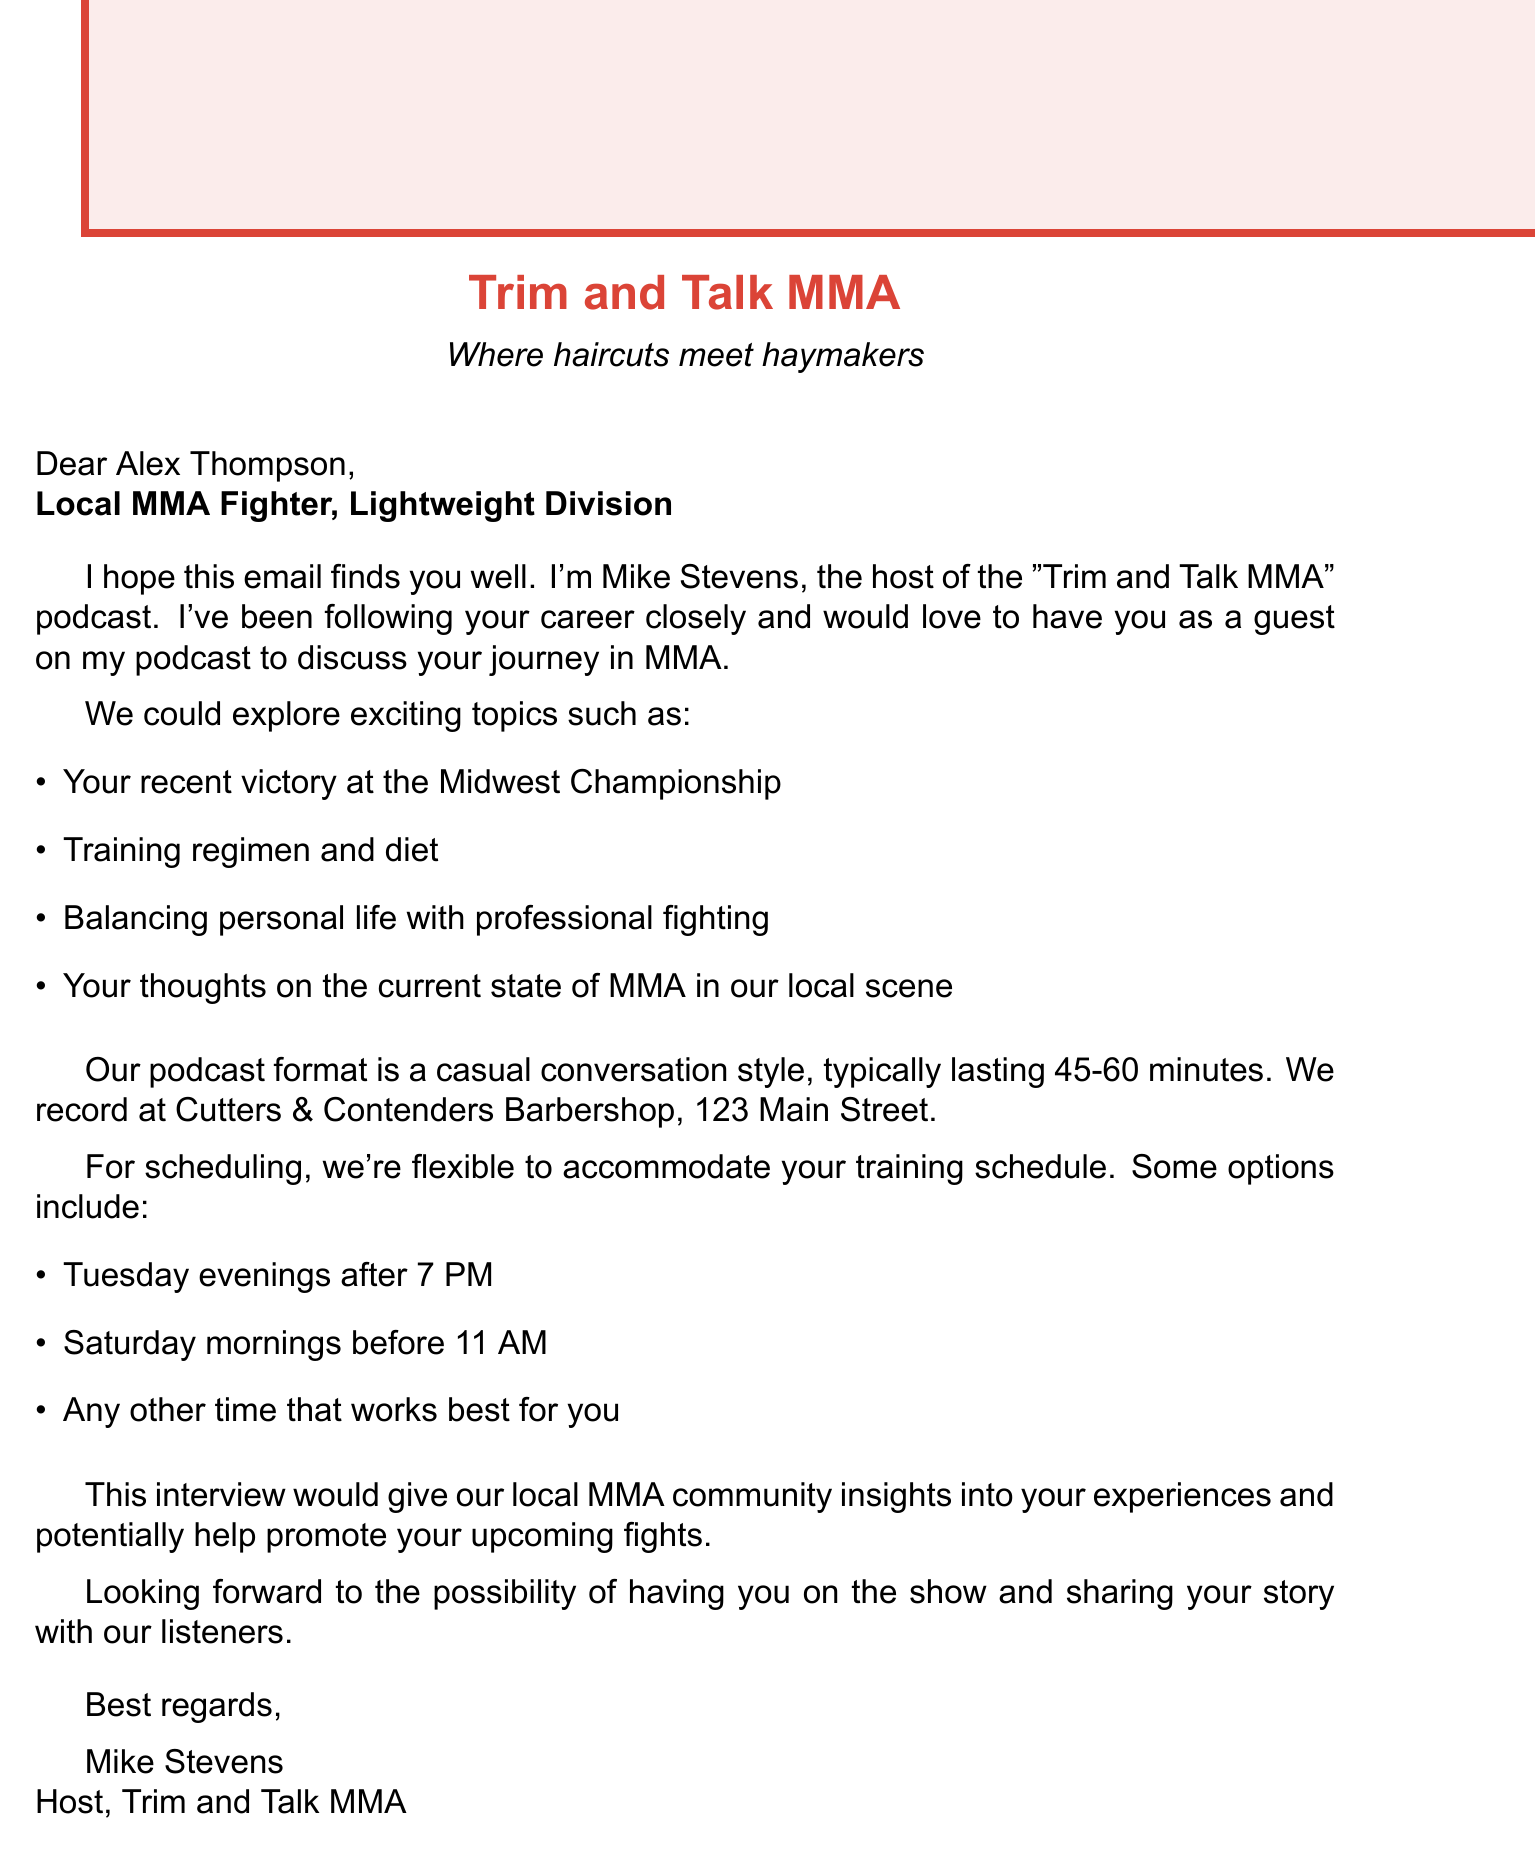What is the name of the podcast? The name of the podcast is mentioned in the document as "Trim and Talk MMA."
Answer: Trim and Talk MMA Who is the host of the podcast? The document states that the host is Mike Stevens.
Answer: Mike Stevens What is the recipient's name? The email mentions the recipient's name as Alex Thompson.
Answer: Alex Thompson What topics are suggested for discussion during the podcast? The document lists several potential topics for discussion in the email.
Answer: Your recent victory at the Midwest Championship, Training regimen and diet, Balancing personal life with professional fighting, Your thoughts on the current state of MMA in our local scene Where is the recording location for the podcast? The document specifies the recording location as Cutters & Contenders Barbershop, 123 Main Street.
Answer: Cutters & Contenders Barbershop, 123 Main Street What is the typical length of the podcast? The document states that the podcast typically lasts 45-60 minutes.
Answer: 45-60 minutes What are the proposed scheduling options for recording? The email provides multiple options for scheduling the recording in the document.
Answer: Tuesday evenings after 7 PM, Saturday mornings before 11 AM, Flexible to accommodate your training schedule What benefit does the interview offer to the local MMA community? The document highlights the mutual benefit of the interview in the email.
Answer: Insights into your experiences and potentially help promote your upcoming fights 